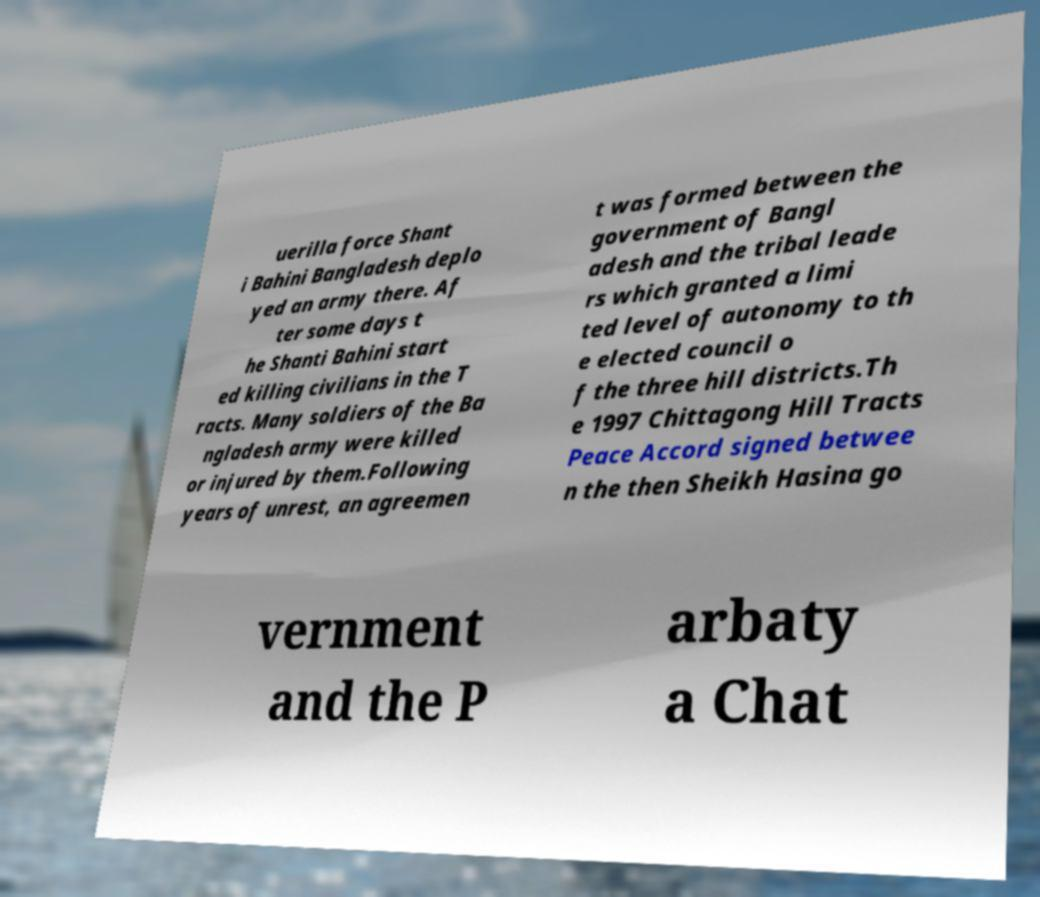For documentation purposes, I need the text within this image transcribed. Could you provide that? uerilla force Shant i Bahini Bangladesh deplo yed an army there. Af ter some days t he Shanti Bahini start ed killing civilians in the T racts. Many soldiers of the Ba ngladesh army were killed or injured by them.Following years of unrest, an agreemen t was formed between the government of Bangl adesh and the tribal leade rs which granted a limi ted level of autonomy to th e elected council o f the three hill districts.Th e 1997 Chittagong Hill Tracts Peace Accord signed betwee n the then Sheikh Hasina go vernment and the P arbaty a Chat 